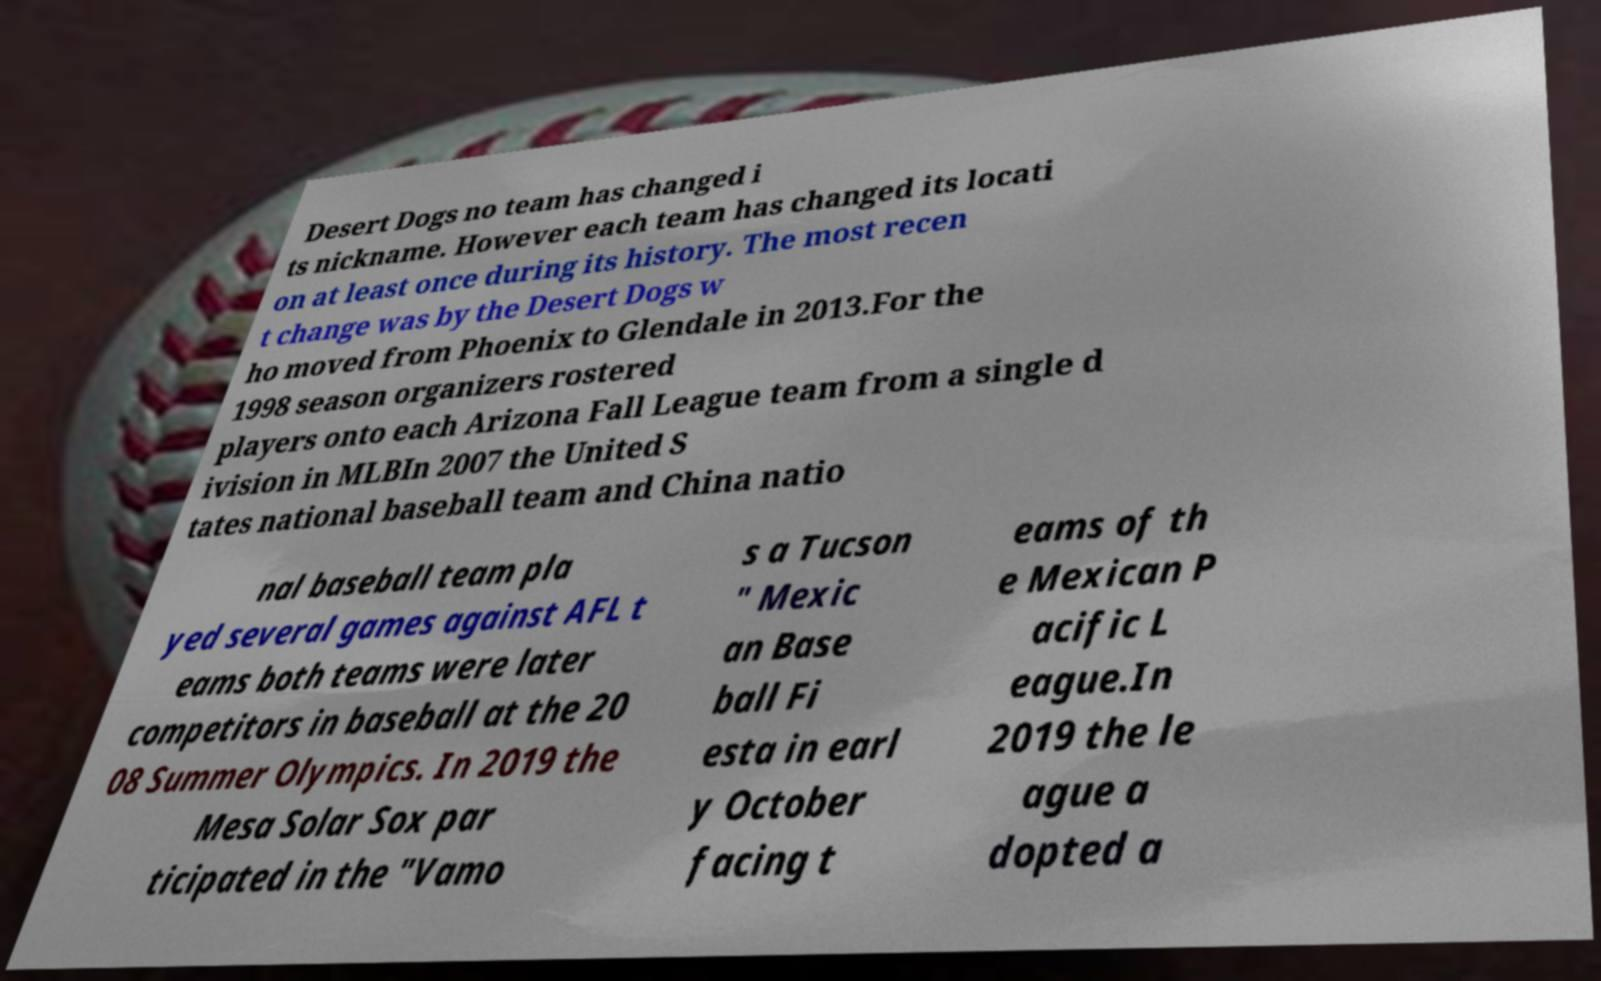There's text embedded in this image that I need extracted. Can you transcribe it verbatim? Desert Dogs no team has changed i ts nickname. However each team has changed its locati on at least once during its history. The most recen t change was by the Desert Dogs w ho moved from Phoenix to Glendale in 2013.For the 1998 season organizers rostered players onto each Arizona Fall League team from a single d ivision in MLBIn 2007 the United S tates national baseball team and China natio nal baseball team pla yed several games against AFL t eams both teams were later competitors in baseball at the 20 08 Summer Olympics. In 2019 the Mesa Solar Sox par ticipated in the "Vamo s a Tucson " Mexic an Base ball Fi esta in earl y October facing t eams of th e Mexican P acific L eague.In 2019 the le ague a dopted a 